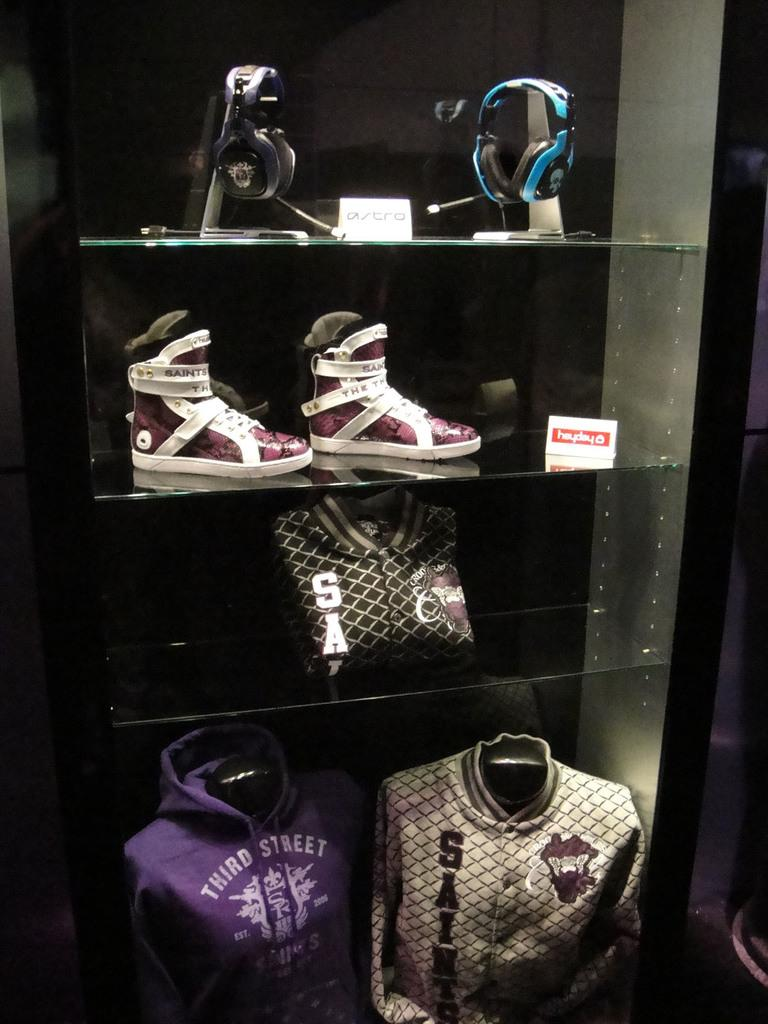What type of storage or display units are present in the image? There are glass shelves in the image. What items can be seen on the top shelf? There are earphones on the top shelf. What type of footwear is on the shelf below the earphones? There are shoes on the shelf below the earphones. What clothing items are on the bottom shelf? There are dresses on the bottom shelf. Can you see any clouds on the glass shelves in the image? No, there are no clouds present on the glass shelves in the image. 